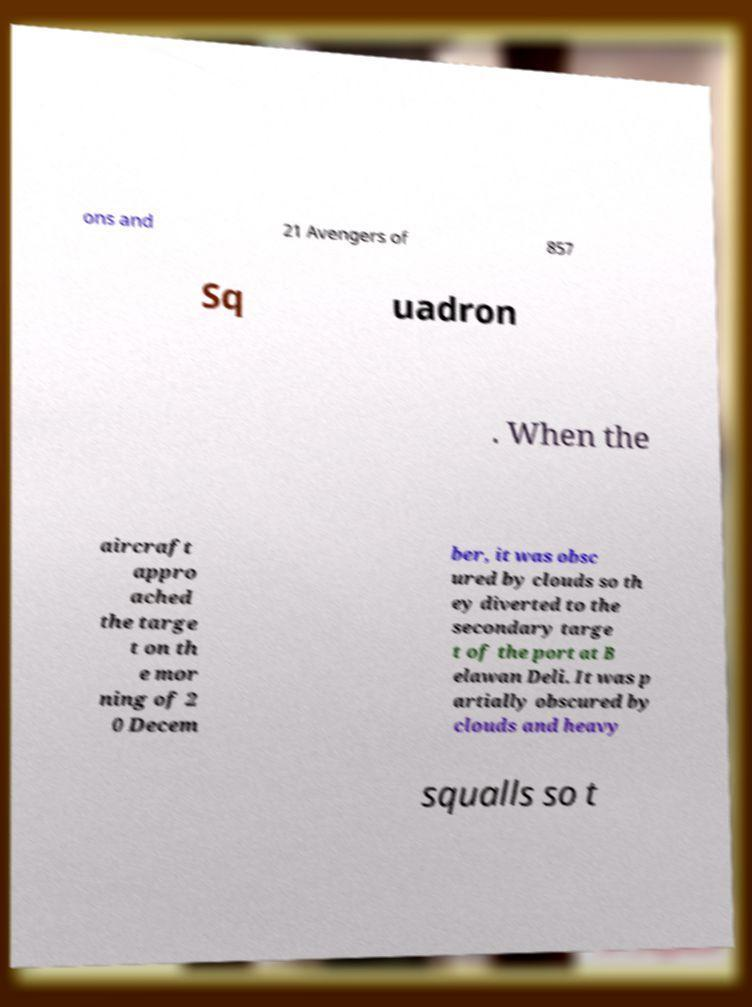For documentation purposes, I need the text within this image transcribed. Could you provide that? ons and 21 Avengers of 857 Sq uadron . When the aircraft appro ached the targe t on th e mor ning of 2 0 Decem ber, it was obsc ured by clouds so th ey diverted to the secondary targe t of the port at B elawan Deli. It was p artially obscured by clouds and heavy squalls so t 